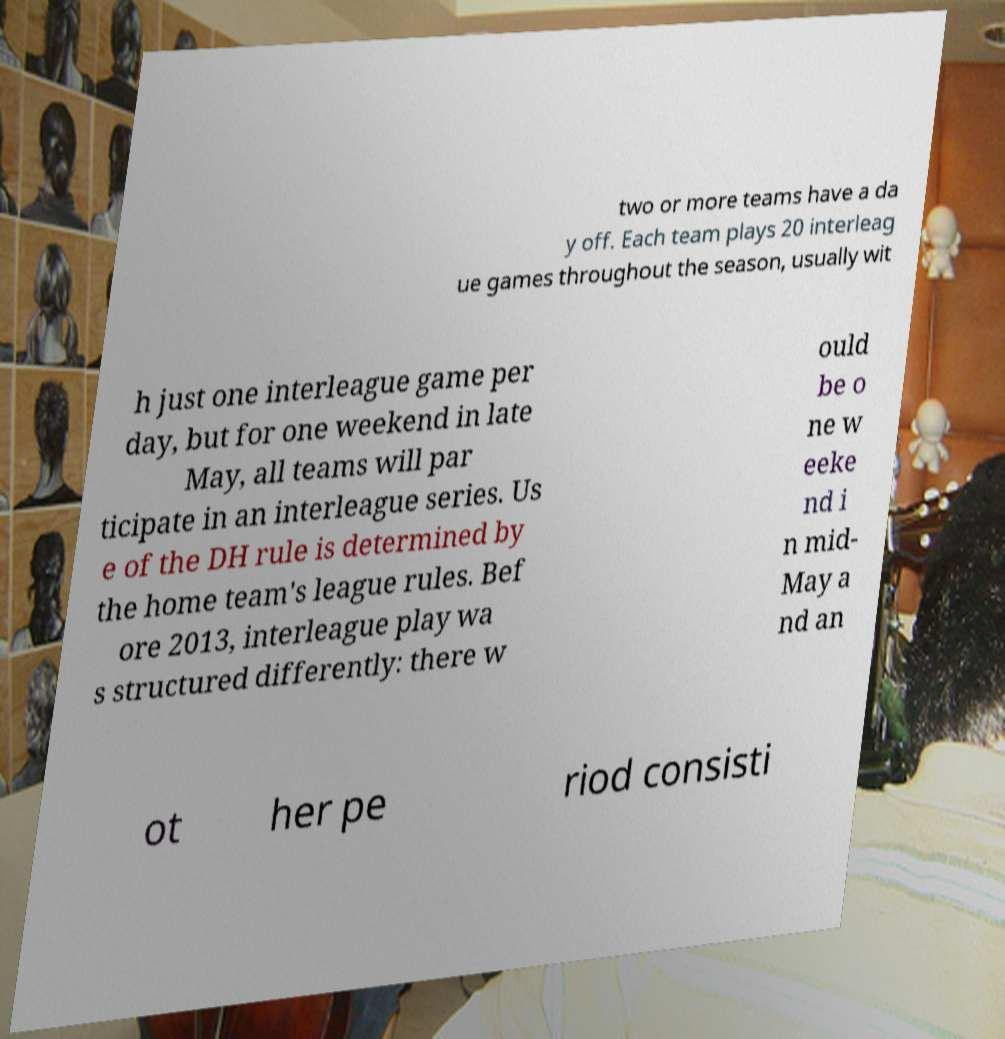Could you assist in decoding the text presented in this image and type it out clearly? two or more teams have a da y off. Each team plays 20 interleag ue games throughout the season, usually wit h just one interleague game per day, but for one weekend in late May, all teams will par ticipate in an interleague series. Us e of the DH rule is determined by the home team's league rules. Bef ore 2013, interleague play wa s structured differently: there w ould be o ne w eeke nd i n mid- May a nd an ot her pe riod consisti 